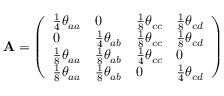<formula> <loc_0><loc_0><loc_500><loc_500>A = \left ( \begin{array} { l l l l } { \frac { 1 } { 4 } \theta _ { a a } } & { 0 } & { \frac { 1 } { 8 } \theta _ { c c } } & { \frac { 1 } { 8 } \theta _ { c d } } \\ { 0 } & { \frac { 1 } { 4 } \theta _ { a b } } & { \frac { 1 } { 8 } \theta _ { c c } } & { \frac { 1 } { 8 } \theta _ { c d } } \\ { \frac { 1 } { 8 } \theta _ { a a } } & { \frac { 1 } { 8 } \theta _ { a b } } & { \frac { 1 } { 4 } \theta _ { c c } } & { 0 } \\ { \frac { 1 } { 8 } \theta _ { a a } } & { \frac { 1 } { 8 } \theta _ { a b } } & { 0 } & { \frac { 1 } { 4 } \theta _ { c d } } \end{array} \right )</formula> 